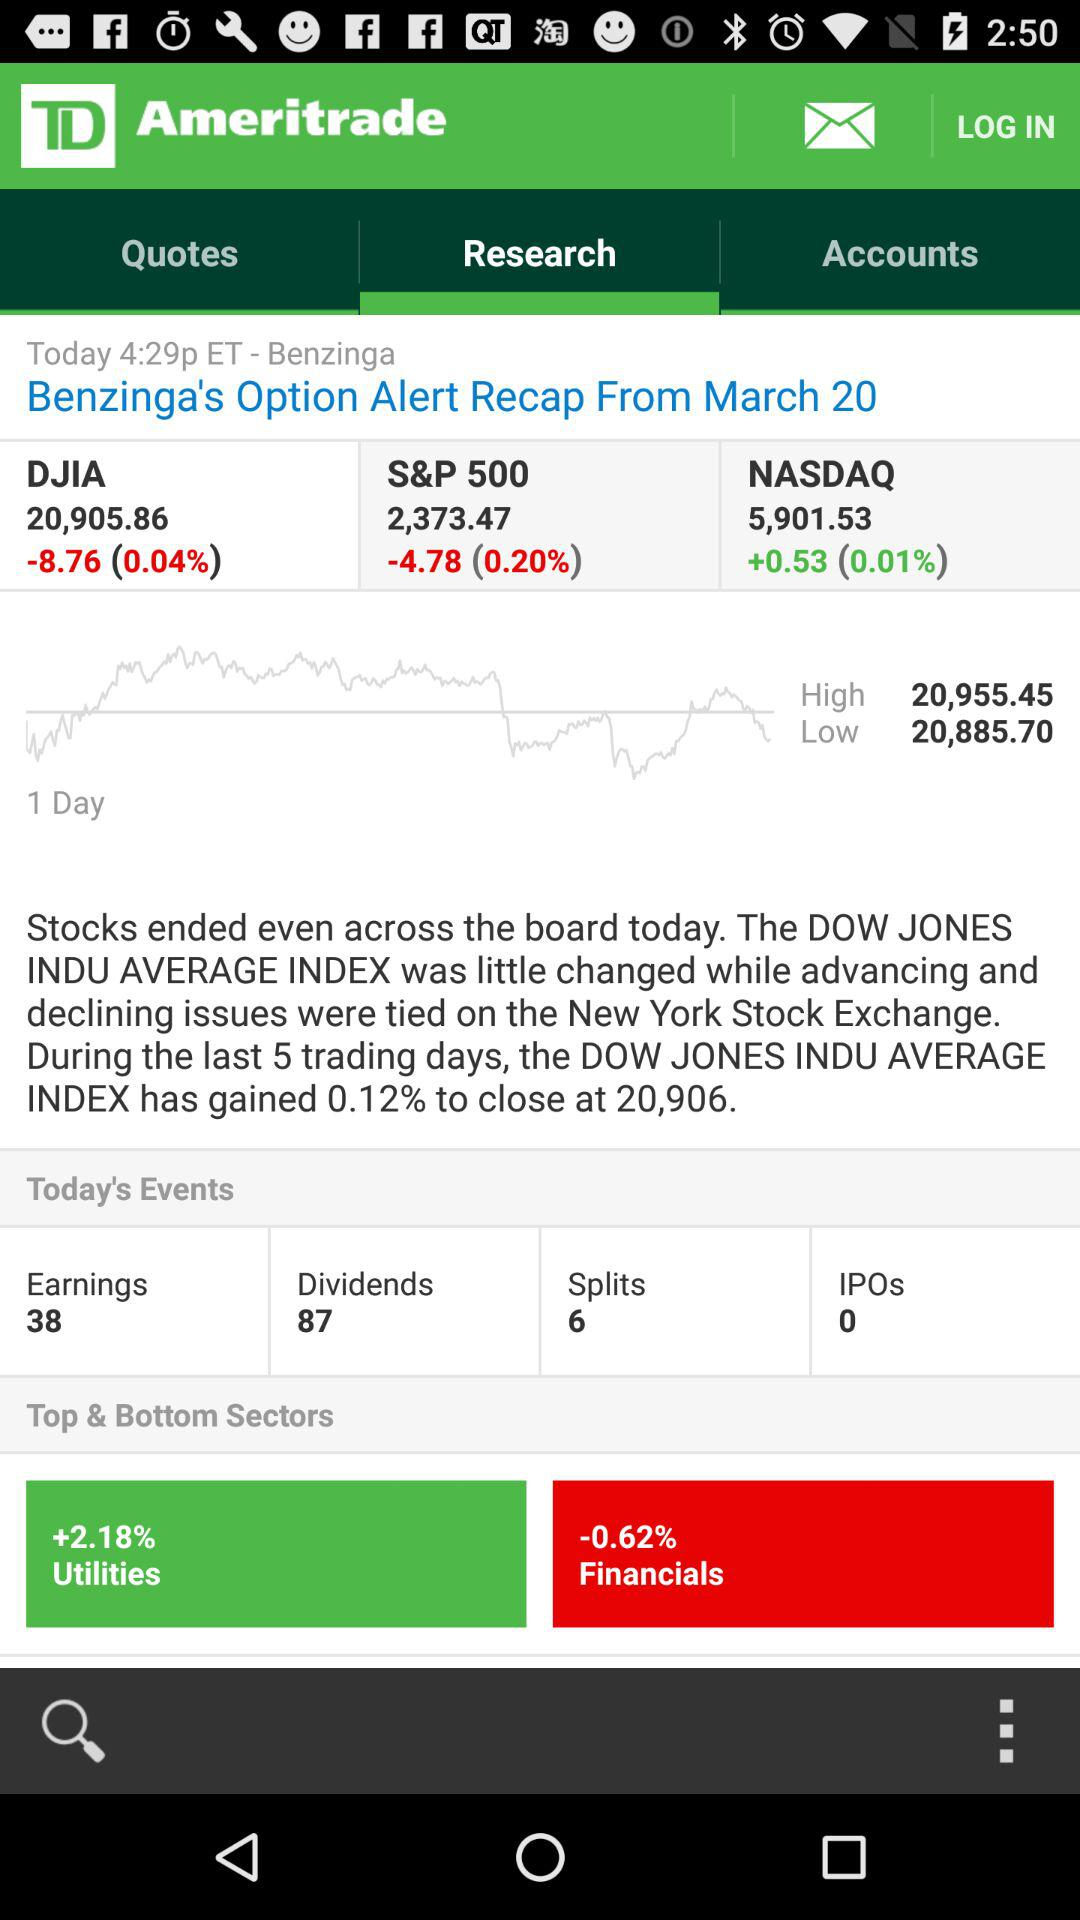Which sector has the highest percentage gain? Utilities 